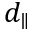Convert formula to latex. <formula><loc_0><loc_0><loc_500><loc_500>d _ { \| }</formula> 